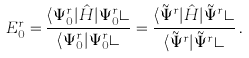<formula> <loc_0><loc_0><loc_500><loc_500>E _ { 0 } ^ { r } = \frac { \langle \Psi ^ { r } _ { 0 } | \hat { H } | \Psi ^ { r } _ { 0 } \rangle } { \langle \Psi ^ { r } _ { 0 } | \Psi ^ { r } _ { 0 } \rangle } = \frac { \langle \tilde { \Psi } ^ { r } | \hat { H } | \tilde { \Psi } ^ { r } \rangle } { \langle \tilde { \Psi } ^ { r } | \tilde { \Psi } ^ { r } \rangle } \, .</formula> 